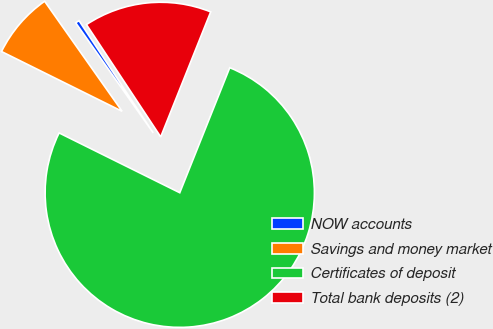Convert chart to OTSL. <chart><loc_0><loc_0><loc_500><loc_500><pie_chart><fcel>NOW accounts<fcel>Savings and money market<fcel>Certificates of deposit<fcel>Total bank deposits (2)<nl><fcel>0.47%<fcel>7.91%<fcel>76.28%<fcel>15.35%<nl></chart> 